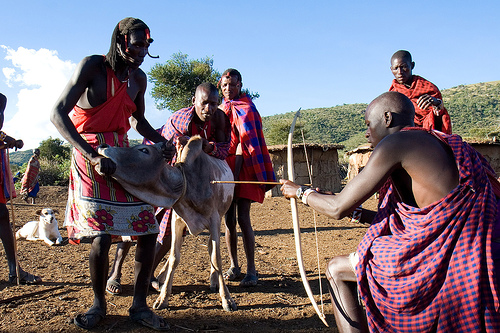<image>
Can you confirm if the bow is next to the cow? Yes. The bow is positioned adjacent to the cow, located nearby in the same general area. 